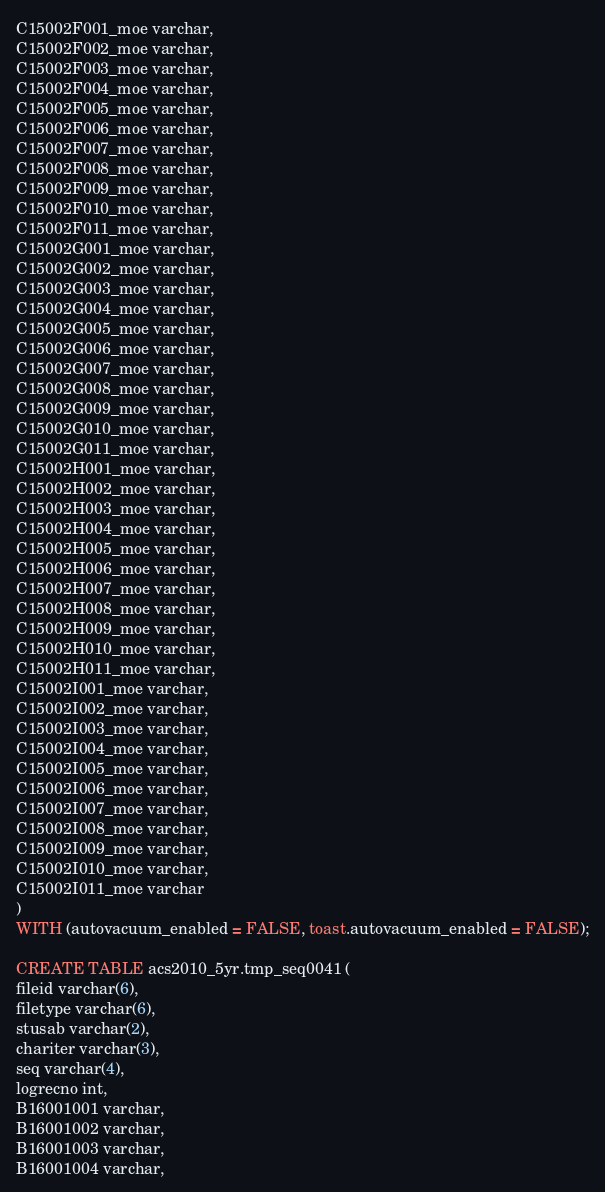Convert code to text. <code><loc_0><loc_0><loc_500><loc_500><_SQL_>C15002F001_moe varchar,
C15002F002_moe varchar,
C15002F003_moe varchar,
C15002F004_moe varchar,
C15002F005_moe varchar,
C15002F006_moe varchar,
C15002F007_moe varchar,
C15002F008_moe varchar,
C15002F009_moe varchar,
C15002F010_moe varchar,
C15002F011_moe varchar,
C15002G001_moe varchar,
C15002G002_moe varchar,
C15002G003_moe varchar,
C15002G004_moe varchar,
C15002G005_moe varchar,
C15002G006_moe varchar,
C15002G007_moe varchar,
C15002G008_moe varchar,
C15002G009_moe varchar,
C15002G010_moe varchar,
C15002G011_moe varchar,
C15002H001_moe varchar,
C15002H002_moe varchar,
C15002H003_moe varchar,
C15002H004_moe varchar,
C15002H005_moe varchar,
C15002H006_moe varchar,
C15002H007_moe varchar,
C15002H008_moe varchar,
C15002H009_moe varchar,
C15002H010_moe varchar,
C15002H011_moe varchar,
C15002I001_moe varchar,
C15002I002_moe varchar,
C15002I003_moe varchar,
C15002I004_moe varchar,
C15002I005_moe varchar,
C15002I006_moe varchar,
C15002I007_moe varchar,
C15002I008_moe varchar,
C15002I009_moe varchar,
C15002I010_moe varchar,
C15002I011_moe varchar
)
WITH (autovacuum_enabled = FALSE, toast.autovacuum_enabled = FALSE);

CREATE TABLE acs2010_5yr.tmp_seq0041 (
fileid varchar(6),
filetype varchar(6),
stusab varchar(2),
chariter varchar(3),
seq varchar(4),
logrecno int,
B16001001 varchar,
B16001002 varchar,
B16001003 varchar,
B16001004 varchar,</code> 